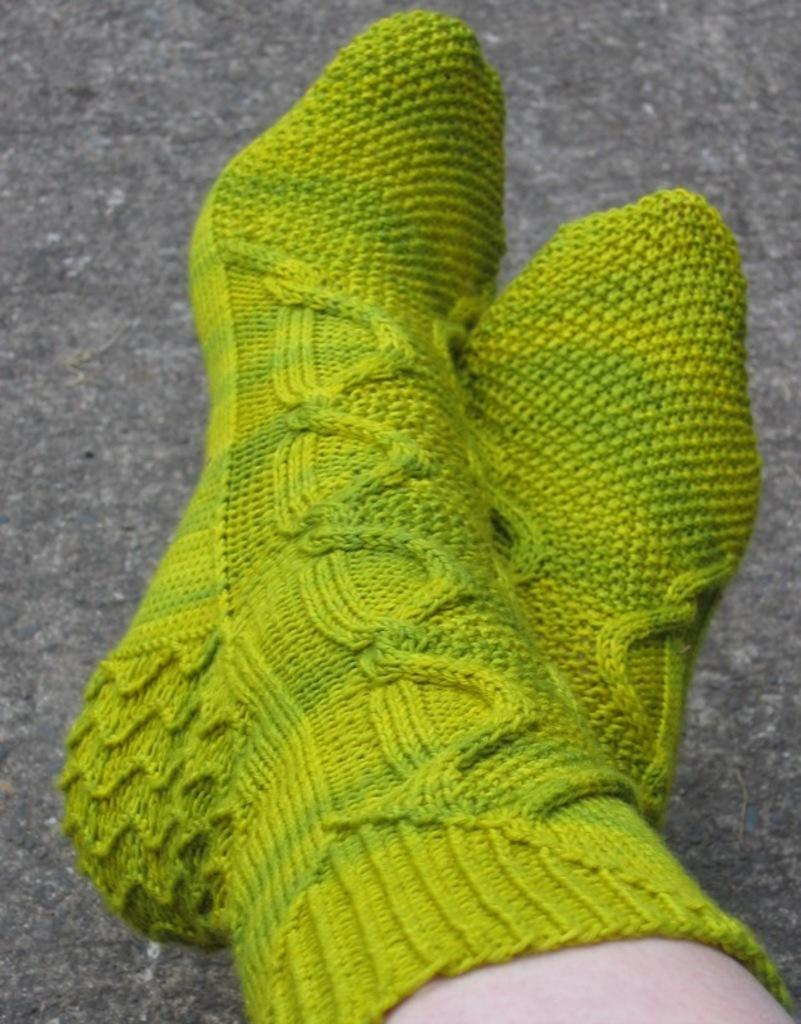What body parts are visible in the image? There are persons' legs visible in the image. What are the persons wearing on their feet? The persons are wearing socks. What type of surface is at the bottom of the image? There is a floor at the bottom of the image. What type of plants can be seen growing on the shelf in the image? There is no shelf or plants present in the image; it only shows persons' legs and socks. 